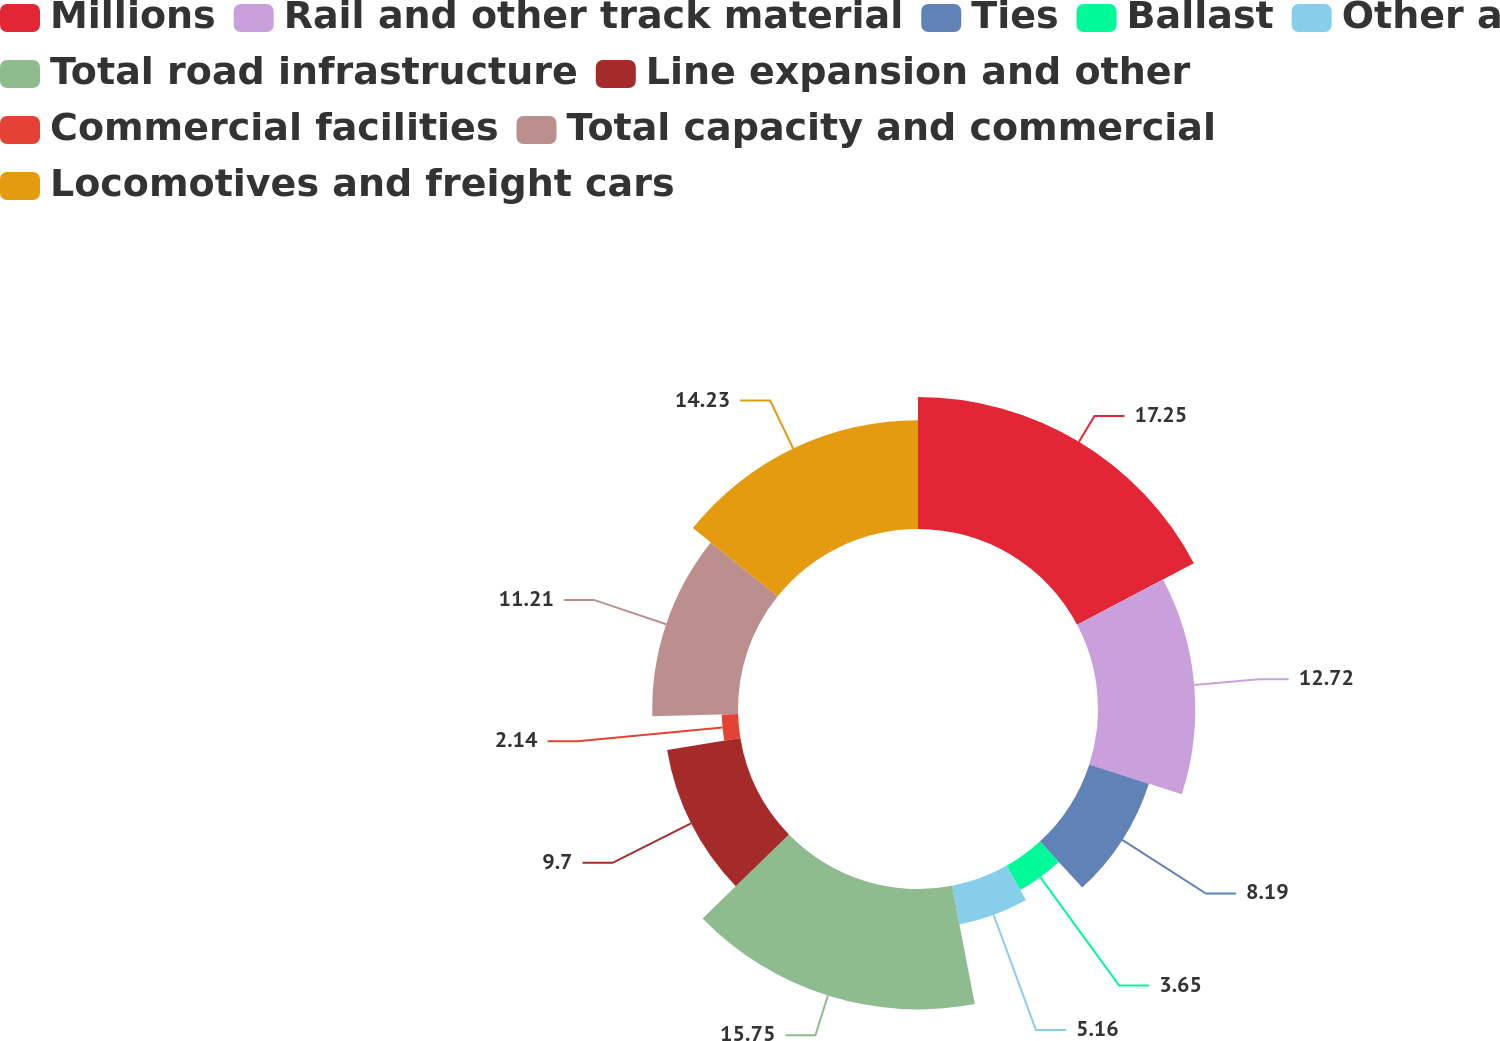Convert chart. <chart><loc_0><loc_0><loc_500><loc_500><pie_chart><fcel>Millions<fcel>Rail and other track material<fcel>Ties<fcel>Ballast<fcel>Other a<fcel>Total road infrastructure<fcel>Line expansion and other<fcel>Commercial facilities<fcel>Total capacity and commercial<fcel>Locomotives and freight cars<nl><fcel>17.26%<fcel>12.72%<fcel>8.19%<fcel>3.65%<fcel>5.16%<fcel>15.75%<fcel>9.7%<fcel>2.14%<fcel>11.21%<fcel>14.23%<nl></chart> 